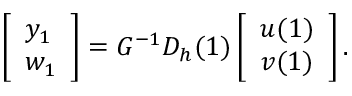Convert formula to latex. <formula><loc_0><loc_0><loc_500><loc_500>\left [ \begin{array} { l } { y _ { 1 } } \\ { w _ { 1 } } \end{array} \right ] = G ^ { - 1 } D _ { h } ( 1 ) \left [ \begin{array} { l } { u ( 1 ) } \\ { v ( 1 ) } \end{array} \right ] .</formula> 